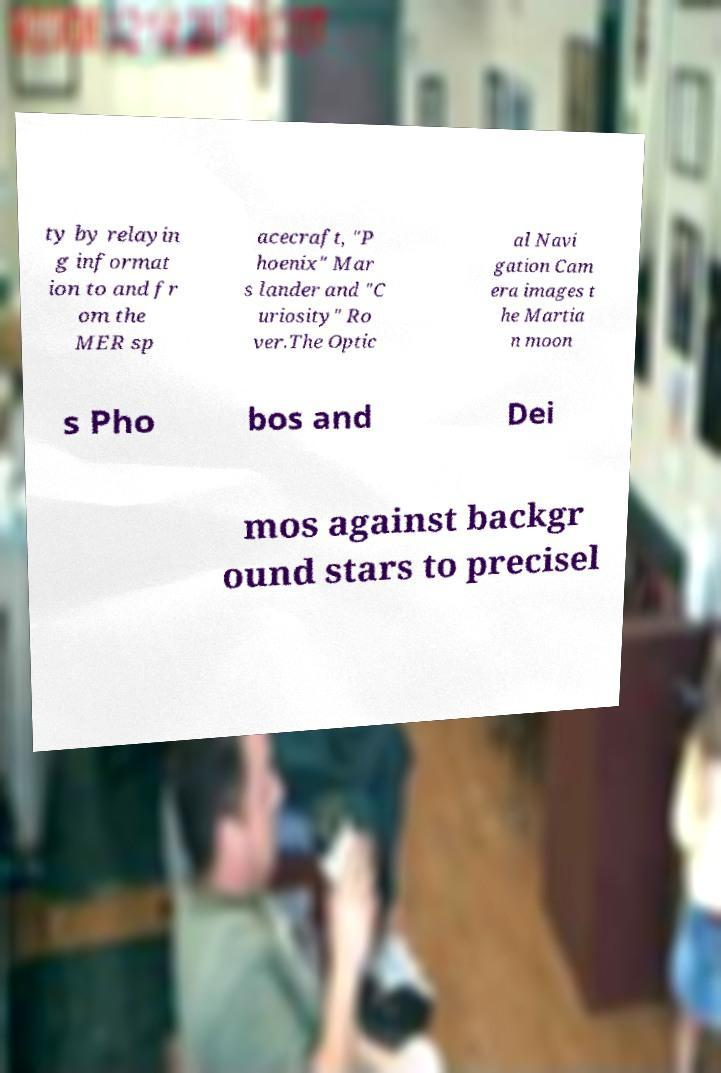Could you extract and type out the text from this image? ty by relayin g informat ion to and fr om the MER sp acecraft, "P hoenix" Mar s lander and "C uriosity" Ro ver.The Optic al Navi gation Cam era images t he Martia n moon s Pho bos and Dei mos against backgr ound stars to precisel 